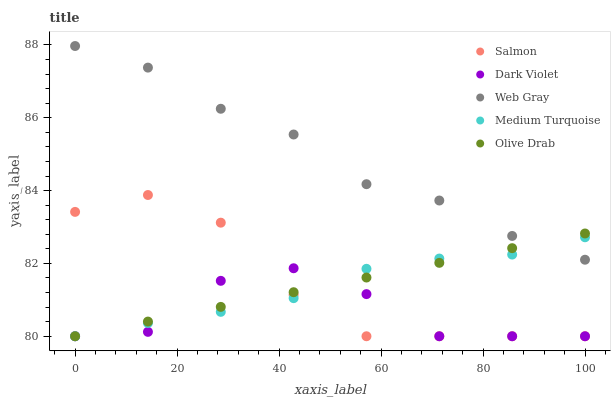Does Dark Violet have the minimum area under the curve?
Answer yes or no. Yes. Does Web Gray have the maximum area under the curve?
Answer yes or no. Yes. Does Salmon have the minimum area under the curve?
Answer yes or no. No. Does Salmon have the maximum area under the curve?
Answer yes or no. No. Is Olive Drab the smoothest?
Answer yes or no. Yes. Is Dark Violet the roughest?
Answer yes or no. Yes. Is Web Gray the smoothest?
Answer yes or no. No. Is Web Gray the roughest?
Answer yes or no. No. Does Olive Drab have the lowest value?
Answer yes or no. Yes. Does Web Gray have the lowest value?
Answer yes or no. No. Does Web Gray have the highest value?
Answer yes or no. Yes. Does Salmon have the highest value?
Answer yes or no. No. Is Dark Violet less than Web Gray?
Answer yes or no. Yes. Is Web Gray greater than Dark Violet?
Answer yes or no. Yes. Does Olive Drab intersect Web Gray?
Answer yes or no. Yes. Is Olive Drab less than Web Gray?
Answer yes or no. No. Is Olive Drab greater than Web Gray?
Answer yes or no. No. Does Dark Violet intersect Web Gray?
Answer yes or no. No. 